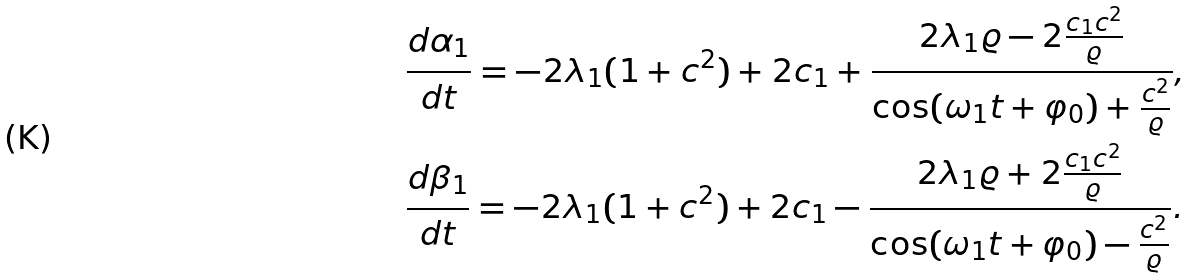Convert formula to latex. <formula><loc_0><loc_0><loc_500><loc_500>& \frac { d \alpha _ { 1 } } { d t } = - 2 \lambda _ { 1 } ( 1 + c ^ { 2 } ) + 2 c _ { 1 } + \frac { 2 \lambda _ { 1 } \varrho - 2 \frac { c _ { 1 } c ^ { 2 } } { \varrho } } { \cos ( \omega _ { 1 } t + \varphi _ { 0 } ) + \frac { c ^ { 2 } } { \varrho } } , \\ & \frac { d \beta _ { 1 } } { d t } = - 2 \lambda _ { 1 } ( 1 + c ^ { 2 } ) + 2 c _ { 1 } - \frac { 2 \lambda _ { 1 } \varrho + 2 \frac { c _ { 1 } c ^ { 2 } } { \varrho } } { \cos ( \omega _ { 1 } t + \varphi _ { 0 } ) - \frac { c ^ { 2 } } { \varrho } } .</formula> 